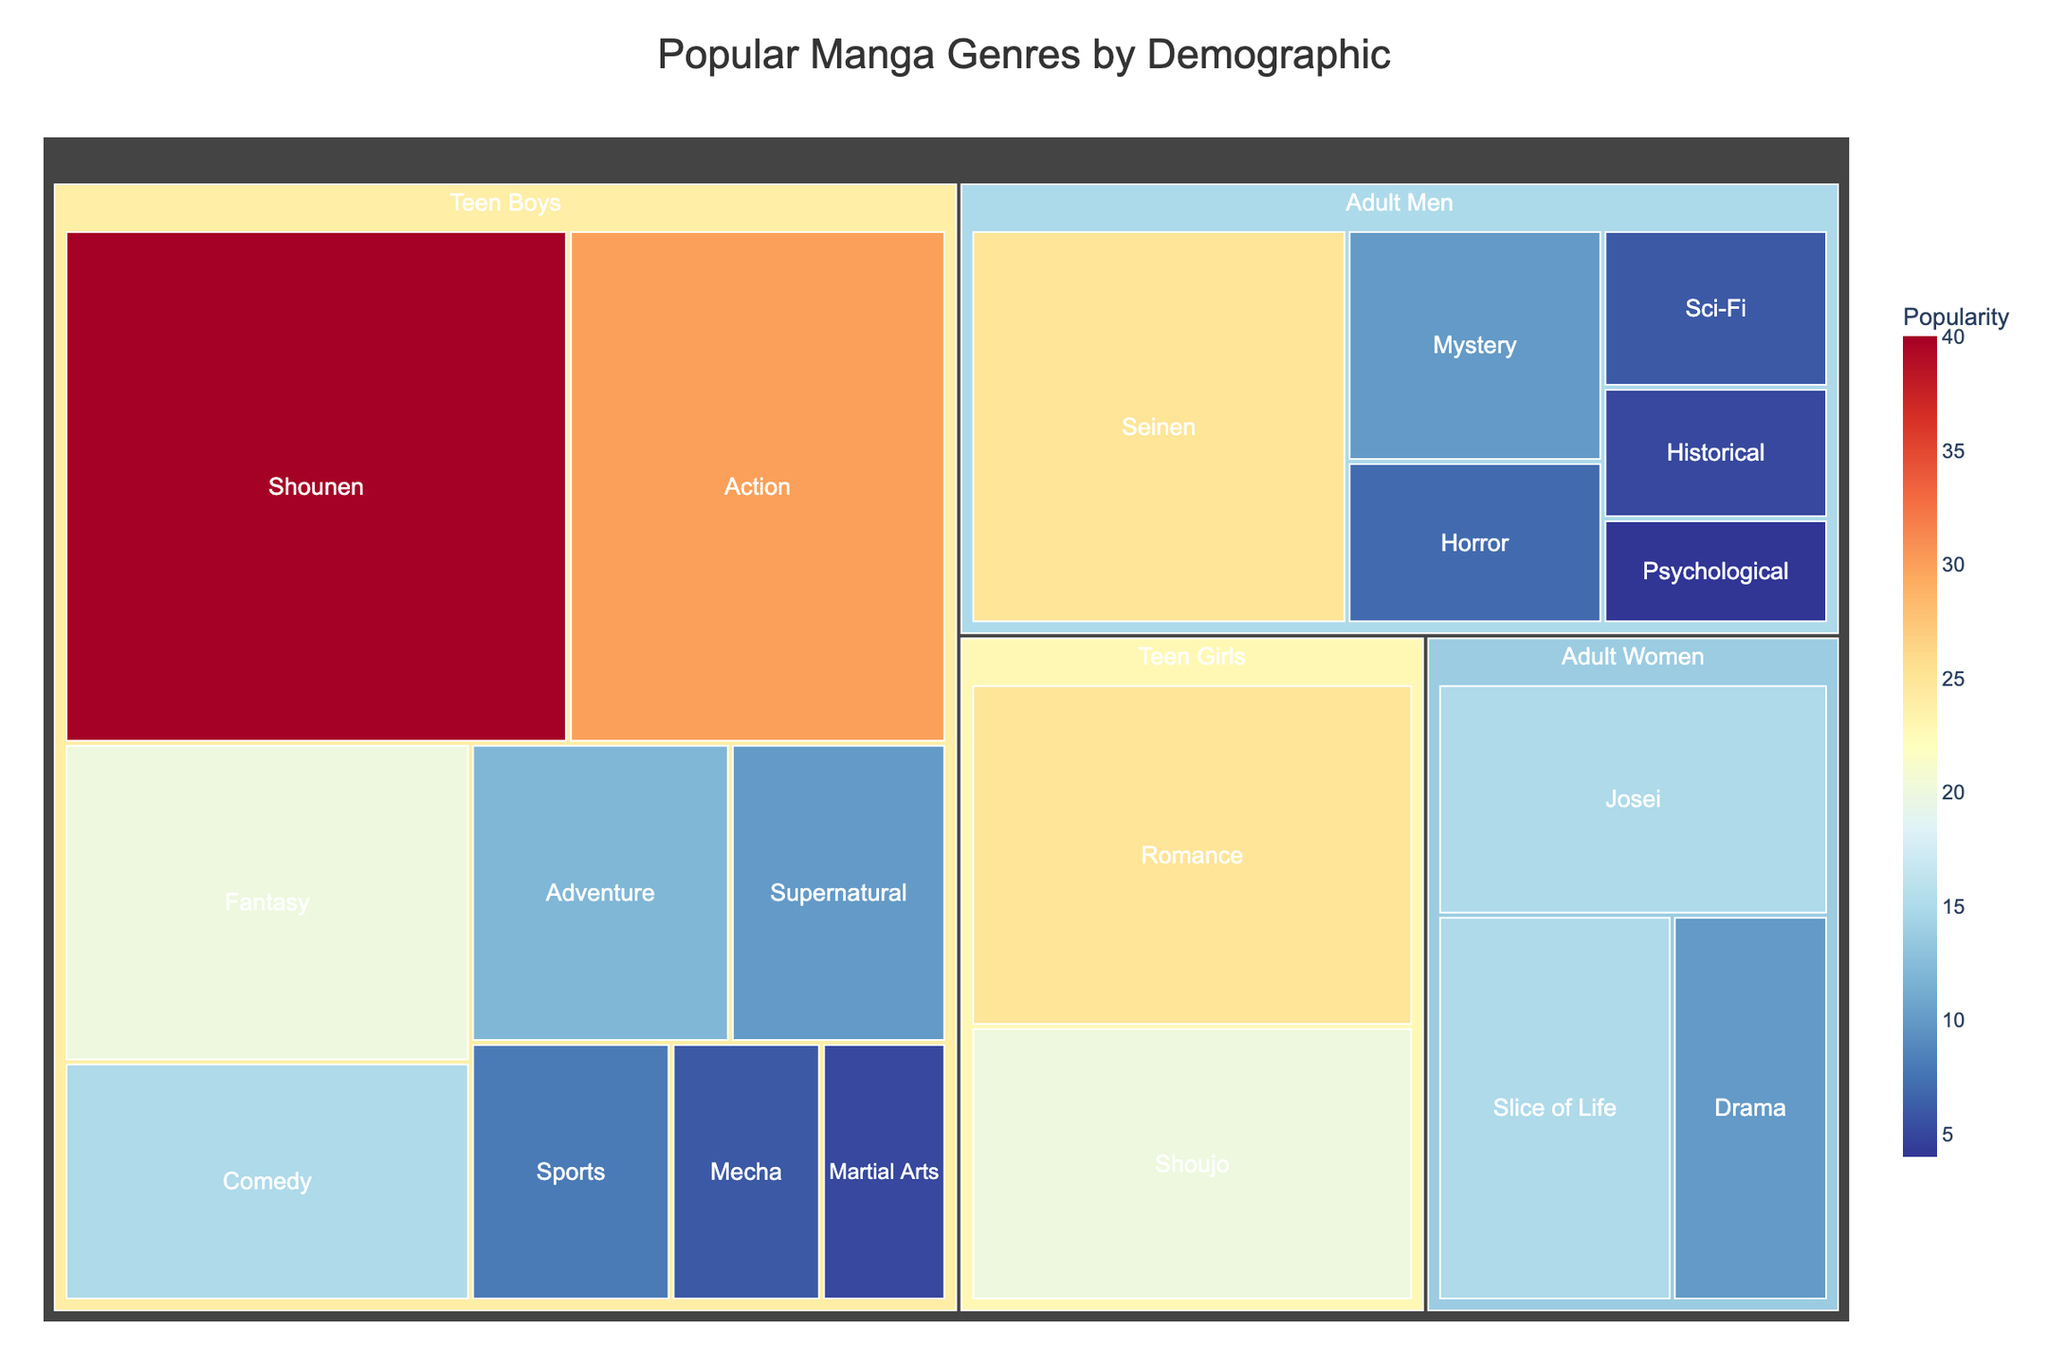What is the most popular manga genre for Teen Boys? To find the most popular genre for Teen Boys, look for the genre with the largest area within the Teen Boys section of the treemap. The genre “Shounen” has the highest popularity at 40.
Answer: Shounen Which demographic has the least popular genre? Identify the smallest tile in the entire treemap regardless of its demographic category. The genre "Psychological" under Adult Men has the lowest popularity at 4.
Answer: Adult Men How many genres are targeted at Adult Women? Count the number of genres listed under the "Adult Women” demographic. The listed genres are "Josei", "Slice of Life", and "Drama".
Answer: 3 What is the combined popularity of all genres targeted at Teen Girls? Add the popularity values of all genres under the "Teen Girls" section. Romance (25) + Shoujo (20) equals 45.
Answer: 45 Which demographic has the second highest total popularity? Sum the popularity values for each demographic and compare. “Teen Boys” sum up to 146, “Adult Men” to 57, ”Teen Girls” to 45, and “Adult Women” to 40. The second highest total popularity is for Adult Men, 57.
Answer: Adult Men Which genre has exactly the same popularity for Teen Boys and Teen Girls? Compare the popularity values of genres within the "Teen Boys" and "Teen Girls" sections to find any matches. None of the genre popularities exactly match between these two demographics.
Answer: None How does the popularity of the "Shounen" genre compare to "Seinen"? “Shounen” has a popularity of 40, whereas "Seinen" has 25. This means “Shounen” is 15 points more popular than "Seinen".
Answer: 15 points more popular Which demographic has the highest variety of genres? Count the number of unique genres within each demographic section. “Teen Boys” has the most with 9 distinct genres.
Answer: Teen Boys What is the average popularity of genres targeted at Adult Men? Add the popularity values for all Adult Men genres and divide by the number of those genres. (25 + 10 + 7 + 6 + 5 + 4 equals 57; there are 6 genres) The average is 57 / 6 = 9.5.
Answer: 9.5 Which demographic has the largest tile representation in the treemap? Determine which demographic has the largest collective area in the treemap. "Teen Boys" encompass the largest area, with the most and largest tiles overall.
Answer: Teen Boys 